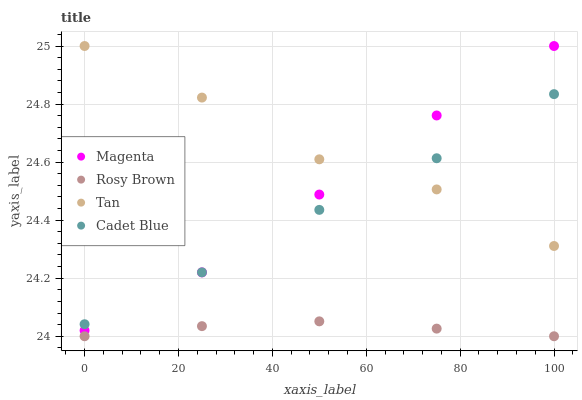Does Rosy Brown have the minimum area under the curve?
Answer yes or no. Yes. Does Tan have the maximum area under the curve?
Answer yes or no. Yes. Does Magenta have the minimum area under the curve?
Answer yes or no. No. Does Magenta have the maximum area under the curve?
Answer yes or no. No. Is Rosy Brown the smoothest?
Answer yes or no. Yes. Is Tan the roughest?
Answer yes or no. Yes. Is Magenta the smoothest?
Answer yes or no. No. Is Magenta the roughest?
Answer yes or no. No. Does Rosy Brown have the lowest value?
Answer yes or no. Yes. Does Magenta have the lowest value?
Answer yes or no. No. Does Tan have the highest value?
Answer yes or no. Yes. Does Rosy Brown have the highest value?
Answer yes or no. No. Is Rosy Brown less than Magenta?
Answer yes or no. Yes. Is Magenta greater than Rosy Brown?
Answer yes or no. Yes. Does Magenta intersect Cadet Blue?
Answer yes or no. Yes. Is Magenta less than Cadet Blue?
Answer yes or no. No. Is Magenta greater than Cadet Blue?
Answer yes or no. No. Does Rosy Brown intersect Magenta?
Answer yes or no. No. 